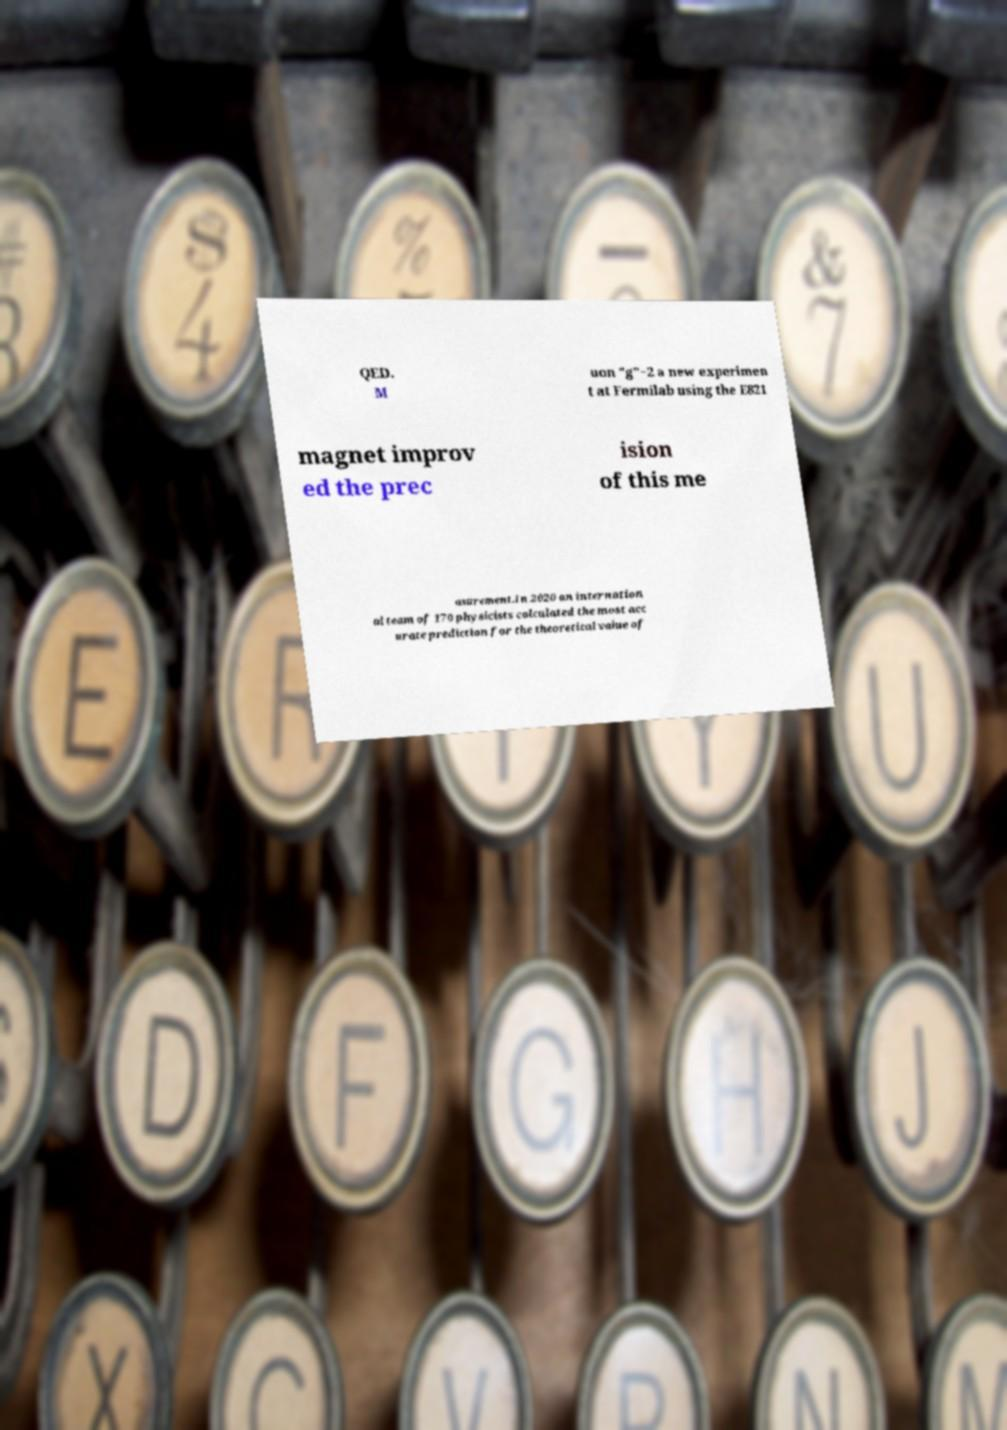What messages or text are displayed in this image? I need them in a readable, typed format. QED. M uon "g"−2 a new experimen t at Fermilab using the E821 magnet improv ed the prec ision of this me asurement.In 2020 an internation al team of 170 physicists calculated the most acc urate prediction for the theoretical value of 